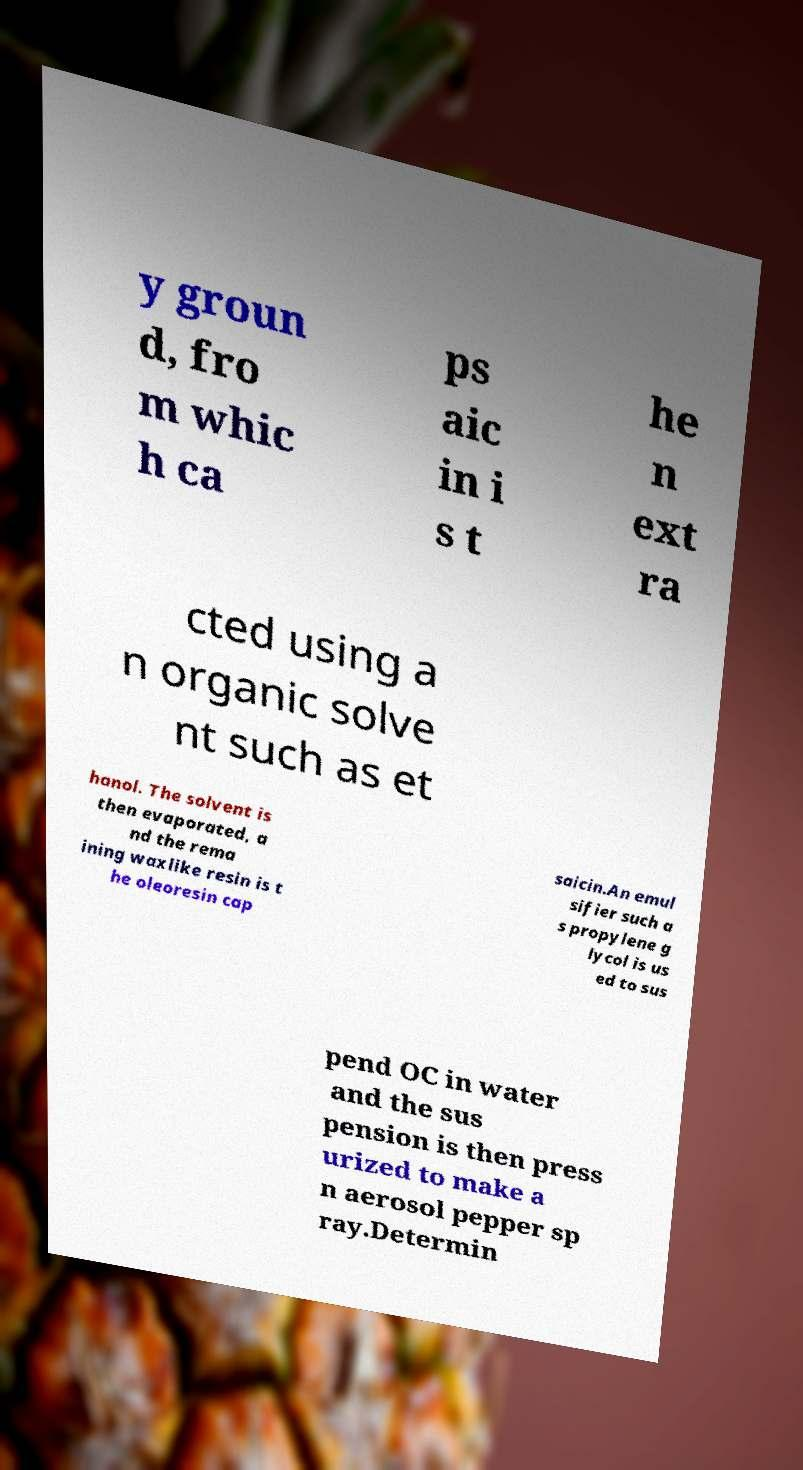Can you accurately transcribe the text from the provided image for me? y groun d, fro m whic h ca ps aic in i s t he n ext ra cted using a n organic solve nt such as et hanol. The solvent is then evaporated, a nd the rema ining waxlike resin is t he oleoresin cap saicin.An emul sifier such a s propylene g lycol is us ed to sus pend OC in water and the sus pension is then press urized to make a n aerosol pepper sp ray.Determin 